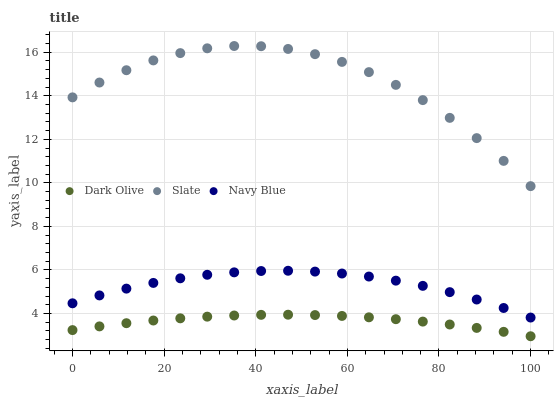Does Dark Olive have the minimum area under the curve?
Answer yes or no. Yes. Does Slate have the maximum area under the curve?
Answer yes or no. Yes. Does Slate have the minimum area under the curve?
Answer yes or no. No. Does Dark Olive have the maximum area under the curve?
Answer yes or no. No. Is Dark Olive the smoothest?
Answer yes or no. Yes. Is Slate the roughest?
Answer yes or no. Yes. Is Slate the smoothest?
Answer yes or no. No. Is Dark Olive the roughest?
Answer yes or no. No. Does Dark Olive have the lowest value?
Answer yes or no. Yes. Does Slate have the lowest value?
Answer yes or no. No. Does Slate have the highest value?
Answer yes or no. Yes. Does Dark Olive have the highest value?
Answer yes or no. No. Is Dark Olive less than Navy Blue?
Answer yes or no. Yes. Is Slate greater than Navy Blue?
Answer yes or no. Yes. Does Dark Olive intersect Navy Blue?
Answer yes or no. No. 